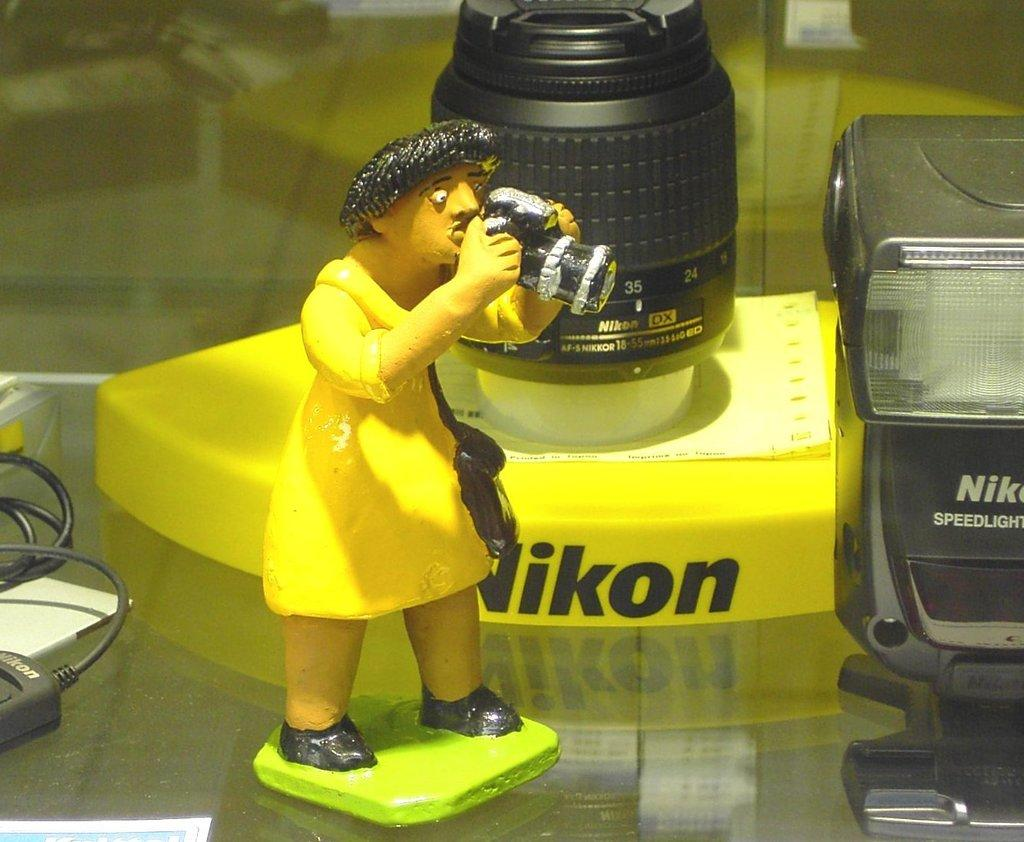What type of surface is visible in the image? There is a glass surface in the image. What is placed on the glass surface? There is a toy and camera gadgets on the glass surface. Are there any additional items on the glass surface? Yes, there are wires on the glass surface. Can you describe the object in the bottom left corner of the image? Unfortunately, the facts provided do not give any information about the object in the bottom left corner of the image. What grade did the boy receive on his last exam, as shown in the image? There is no boy or exam present in the image, so it is not possible to answer that question. 